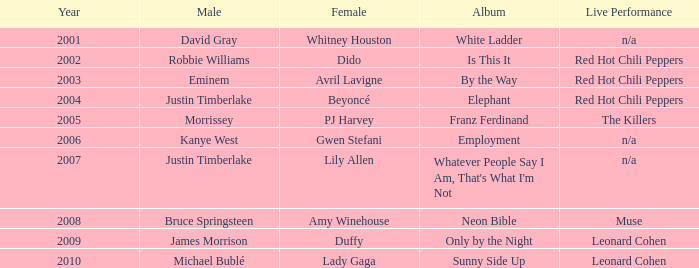Who is the male associate for amy winehouse? Bruce Springsteen. 